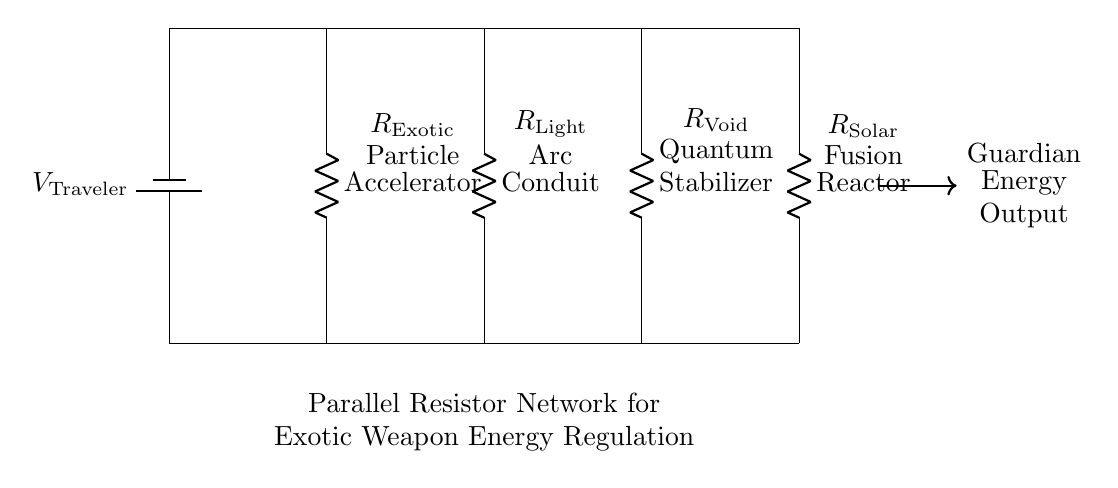What is the voltage supplied by the battery? The voltage supplied by the battery is given as \( V_\text{Traveler} \), indicated at the top left of the circuit.
Answer: V Traveler How many resistors are present in the network? Counting the resistors shown in the circuit, we see four distinct resistors labeled as Exotic, Light, Void, and Solar, confirming the total count to be four.
Answer: 4 What is the role of the Exotic resistor? The Exotic resistor is labeled as the Particle Accelerator, which likely indicates its use in enhancing or regulating the energy within the weapon system in question.
Answer: Particle Accelerator Which resistor predominantly manages Solar energy? The resistor labeled R Solar or Fusion Reactor takes on the responsibility for managing Solar energy within the parallel network specified in the diagram.
Answer: R Solar How does total current splitting occur in this parallel circuit? In a parallel circuit, the total current divides among the branches according to the resistance value of each resistor. The lower the resistance, the higher the current through that pathway, illustrating how energy management is effectively balanced in the design.
Answer: Current divides based on resistance Which component is responsible for Void energy stabilization? The resistor marked as R Void or Quantum Stabilizer is identified in the diagram as the component explicitly tasked with Void energy stabilization.
Answer: R Void 